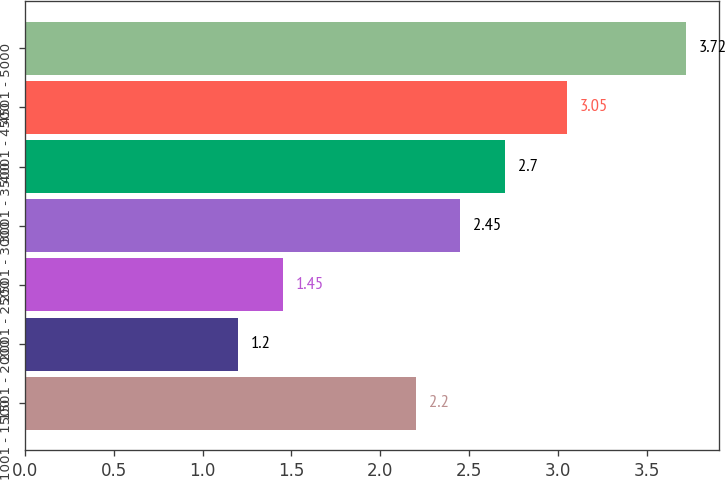Convert chart to OTSL. <chart><loc_0><loc_0><loc_500><loc_500><bar_chart><fcel>1001 - 1500<fcel>1501 - 2000<fcel>2001 - 2500<fcel>2501 - 3000<fcel>3001 - 3500<fcel>4001 - 4500<fcel>4501 - 5000<nl><fcel>2.2<fcel>1.2<fcel>1.45<fcel>2.45<fcel>2.7<fcel>3.05<fcel>3.72<nl></chart> 